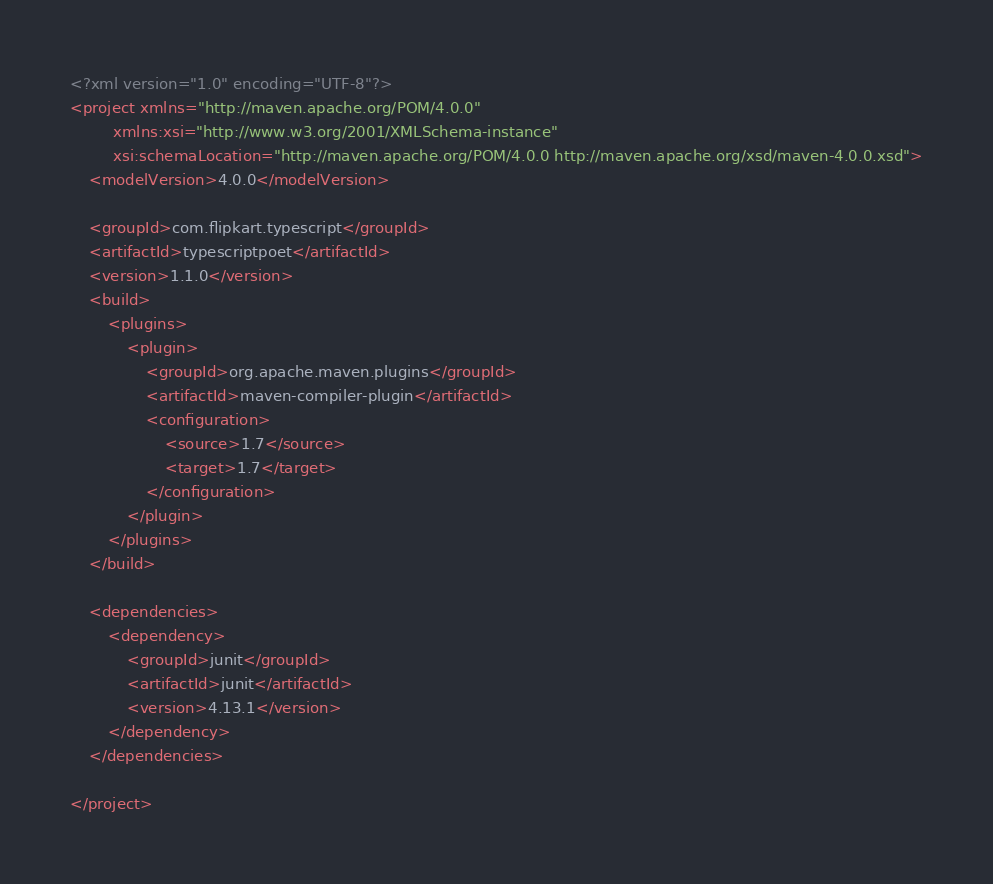Convert code to text. <code><loc_0><loc_0><loc_500><loc_500><_XML_><?xml version="1.0" encoding="UTF-8"?>
<project xmlns="http://maven.apache.org/POM/4.0.0"
         xmlns:xsi="http://www.w3.org/2001/XMLSchema-instance"
         xsi:schemaLocation="http://maven.apache.org/POM/4.0.0 http://maven.apache.org/xsd/maven-4.0.0.xsd">
    <modelVersion>4.0.0</modelVersion>

    <groupId>com.flipkart.typescript</groupId>
    <artifactId>typescriptpoet</artifactId>
    <version>1.1.0</version>
    <build>
        <plugins>
            <plugin>
                <groupId>org.apache.maven.plugins</groupId>
                <artifactId>maven-compiler-plugin</artifactId>
                <configuration>
                    <source>1.7</source>
                    <target>1.7</target>
                </configuration>
            </plugin>
        </plugins>
    </build>

    <dependencies>
        <dependency>
            <groupId>junit</groupId>
            <artifactId>junit</artifactId>
            <version>4.13.1</version>
        </dependency>
    </dependencies>

</project></code> 